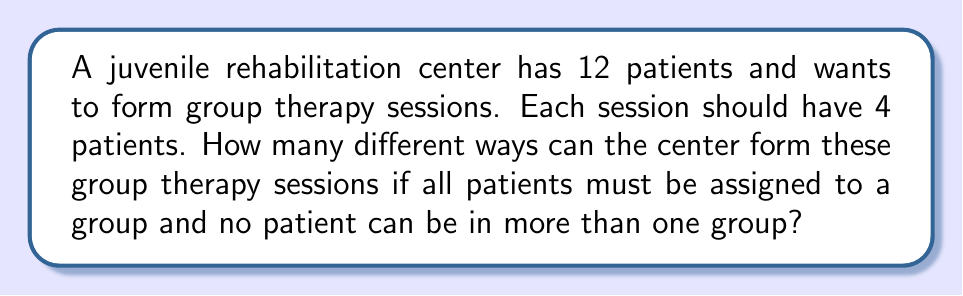What is the answer to this math problem? Let's approach this step-by-step:

1) First, we need to recognize that this is a partition problem. We're dividing 12 patients into 3 groups of 4.

2) This type of problem can be solved using the formula for the number of ways to partition n distinct objects into k groups, where each group has a specific size. The formula is:

   $$\frac{n!}{(n_1!)(n_2!)...(n_k!)}$$

   Where n is the total number of objects, and n1, n2, ..., nk are the sizes of each group.

3) In our case:
   n = 12 (total patients)
   k = 3 (number of groups)
   n1 = n2 = n3 = 4 (size of each group)

4) Plugging these values into our formula:

   $$\frac{12!}{(4!)(4!)(4!)}$$

5) Let's calculate this:
   
   $$\frac{12 * 11 * 10 * 9 * 8!}{(4 * 3 * 2 * 1)(4 * 3 * 2 * 1)(4 * 3 * 2 * 1)}$$

6) Simplify:

   $$\frac{12 * 11 * 10 * 9}{24 * 24} = \frac{11880}{576} = 20.625$$

7) Since we're dealing with whole groups, we round down to the nearest whole number.
Answer: 20 